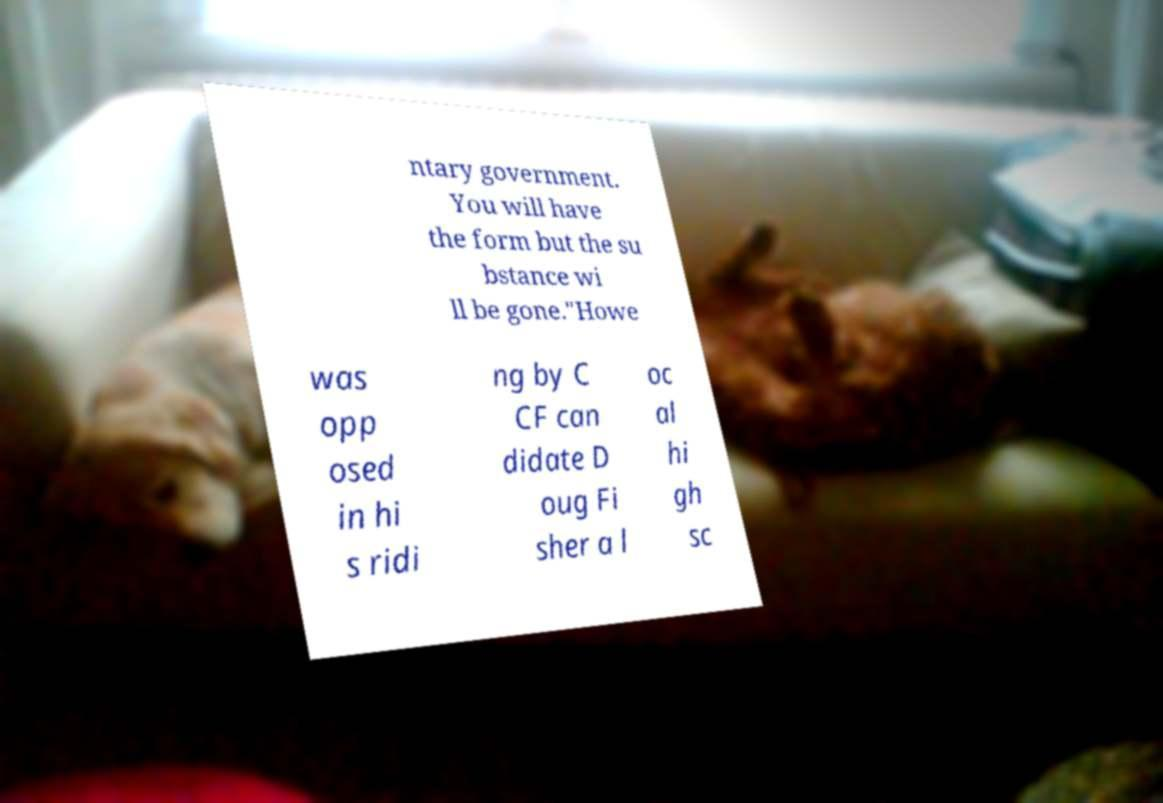Please identify and transcribe the text found in this image. ntary government. You will have the form but the su bstance wi ll be gone."Howe was opp osed in hi s ridi ng by C CF can didate D oug Fi sher a l oc al hi gh sc 